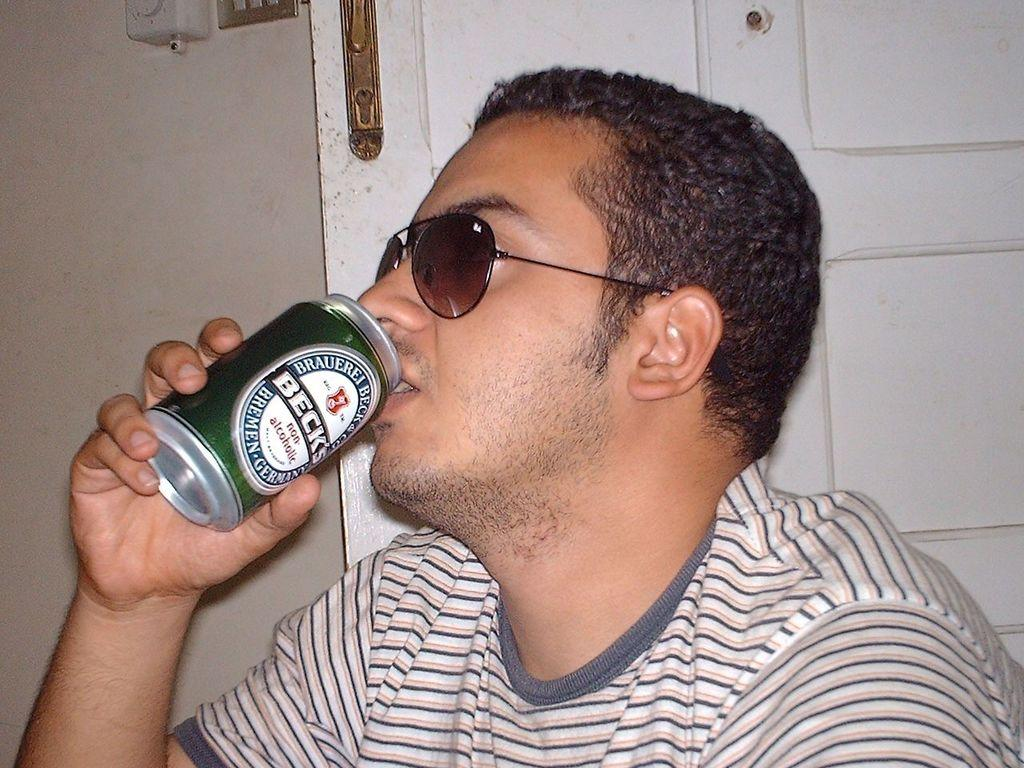What is the main subject of the image? The main subject of the image is a man. What is the man holding in the image? The man is holding a can in the image. What type of eyewear is the man wearing? The man is wearing shades in the image. What type of flag is visible in the image? There is no flag present in the image. What animal can be seen interacting with the man in the image? There is no animal present in the image. 